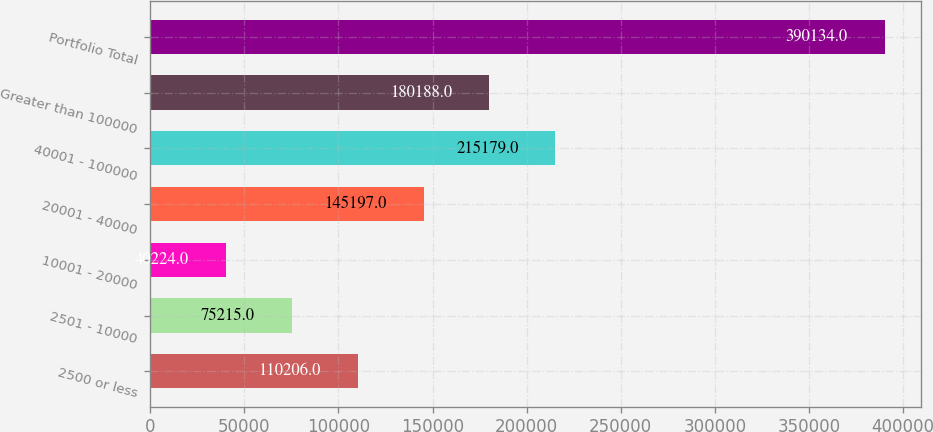Convert chart. <chart><loc_0><loc_0><loc_500><loc_500><bar_chart><fcel>2500 or less<fcel>2501 - 10000<fcel>10001 - 20000<fcel>20001 - 40000<fcel>40001 - 100000<fcel>Greater than 100000<fcel>Portfolio Total<nl><fcel>110206<fcel>75215<fcel>40224<fcel>145197<fcel>215179<fcel>180188<fcel>390134<nl></chart> 